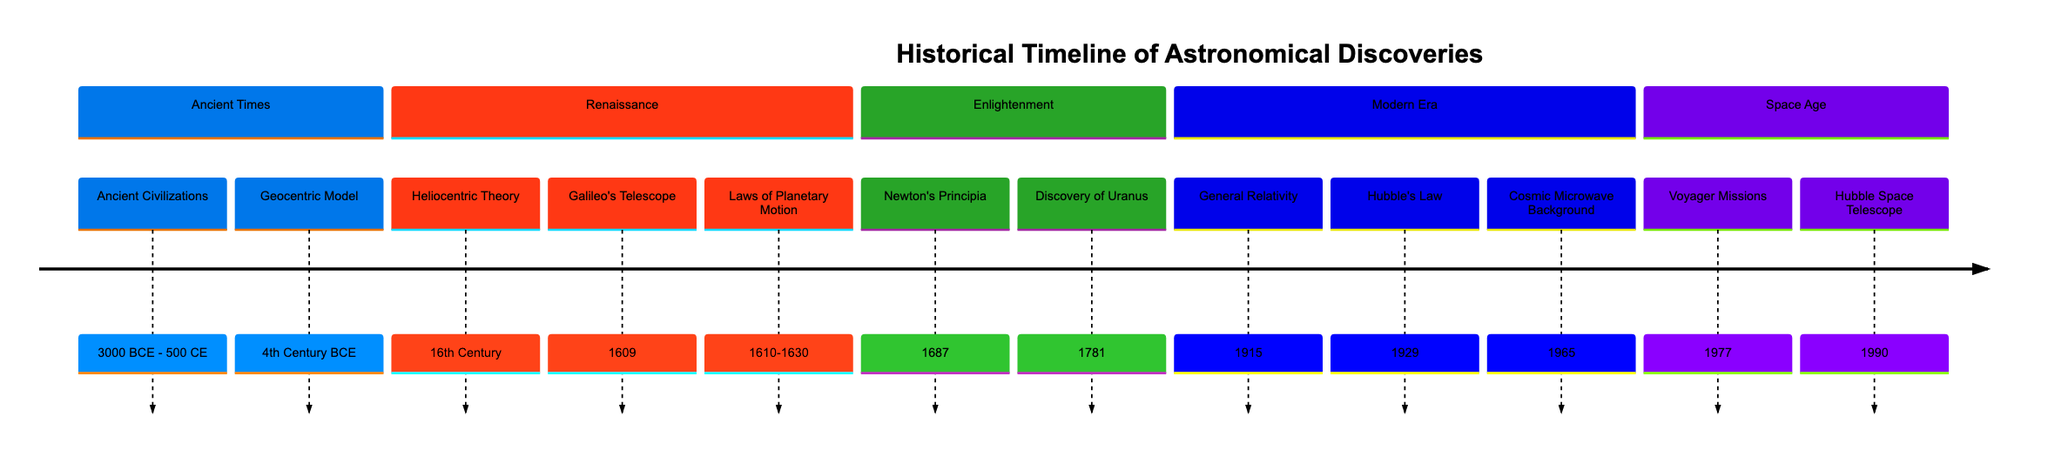What is the starting year for ancient civilizations in astronomy? The diagram indicates that ancient civilizations in astronomy began around 3000 BCE, as shown in the section labeled 'Ancient Times' with the corresponding date.
Answer: 3000 BCE Which significant theory emerged in the 16th Century? The 'Renaissance' section of the diagram highlights the Heliocentric Theory as a key milestone that was proposed in the 16th Century, indicating its importance in astronomical thought.
Answer: Heliocentric Theory How many discoveries are listed in the Modern Era section? By examining the 'Modern Era' section, we can count three distinct discoveries: General Relativity, Hubble's Law, and Cosmic Microwave Background. Thus, the total count of discoveries in this section is three.
Answer: 3 What year did the Hubble Space Telescope launch? The diagram specifies that the Hubble Space Telescope was launched in 1990, indicated within the 'Space Age' section of the timeline.
Answer: 1990 Which discovery occurred in 1781? The diagram directly mentions the discovery of Uranus taking place in the year 1781, clearly stated in the 'Enlightenment' section as a significant event in the timeline of astronomical discoveries.
Answer: Discovery of Uranus What is the impact of the Voyager Missions as per the timeline? The timeline does not explicitly state the impact of the Voyager Missions, but it indicates their launch in 1977 as a milestone in the 'Space Age' section, suggesting a significant exploration effort in astronomy.
Answer: Significant exploration effort What landmark publication was released in 1687? According to the 'Enlightenment' section of the diagram, Newton's Principia was published in 1687, which is a crucial publication that shaped modern physics and astronomy.
Answer: Newton's Principia How many sections are depicted in the timeline? The diagram is structured with five distinct sections: Ancient Times, Renaissance, Enlightenment, Modern Era, and Space Age. Counting each section gives a total of five sections depicted in the timeline.
Answer: 5 Which node represents discoveries made in the 20th Century? The 'Modern Era' section, which includes General Relativity (1915), Hubble's Law (1929), and Cosmic Microwave Background (1965), indicates nodes that represent significant discoveries made in the 20th Century.
Answer: General Relativity, Hubble's Law, Cosmic Microwave Background 